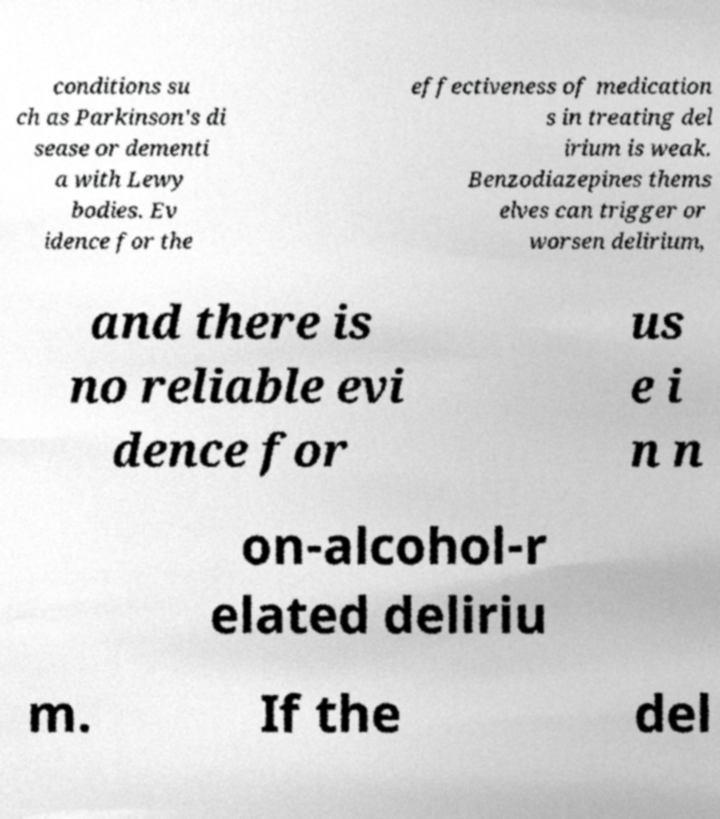There's text embedded in this image that I need extracted. Can you transcribe it verbatim? conditions su ch as Parkinson's di sease or dementi a with Lewy bodies. Ev idence for the effectiveness of medication s in treating del irium is weak. Benzodiazepines thems elves can trigger or worsen delirium, and there is no reliable evi dence for us e i n n on-alcohol-r elated deliriu m. If the del 